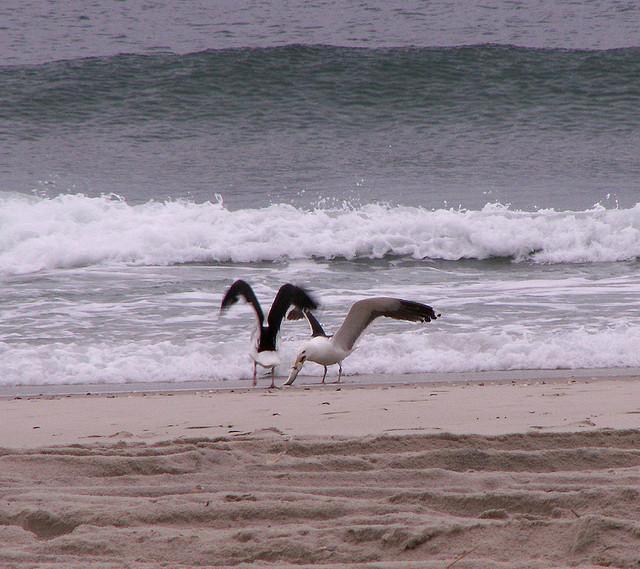How many seagulls are shown?
Give a very brief answer. 2. How many birds are in the picture?
Give a very brief answer. 2. 